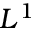Convert formula to latex. <formula><loc_0><loc_0><loc_500><loc_500>L ^ { 1 }</formula> 